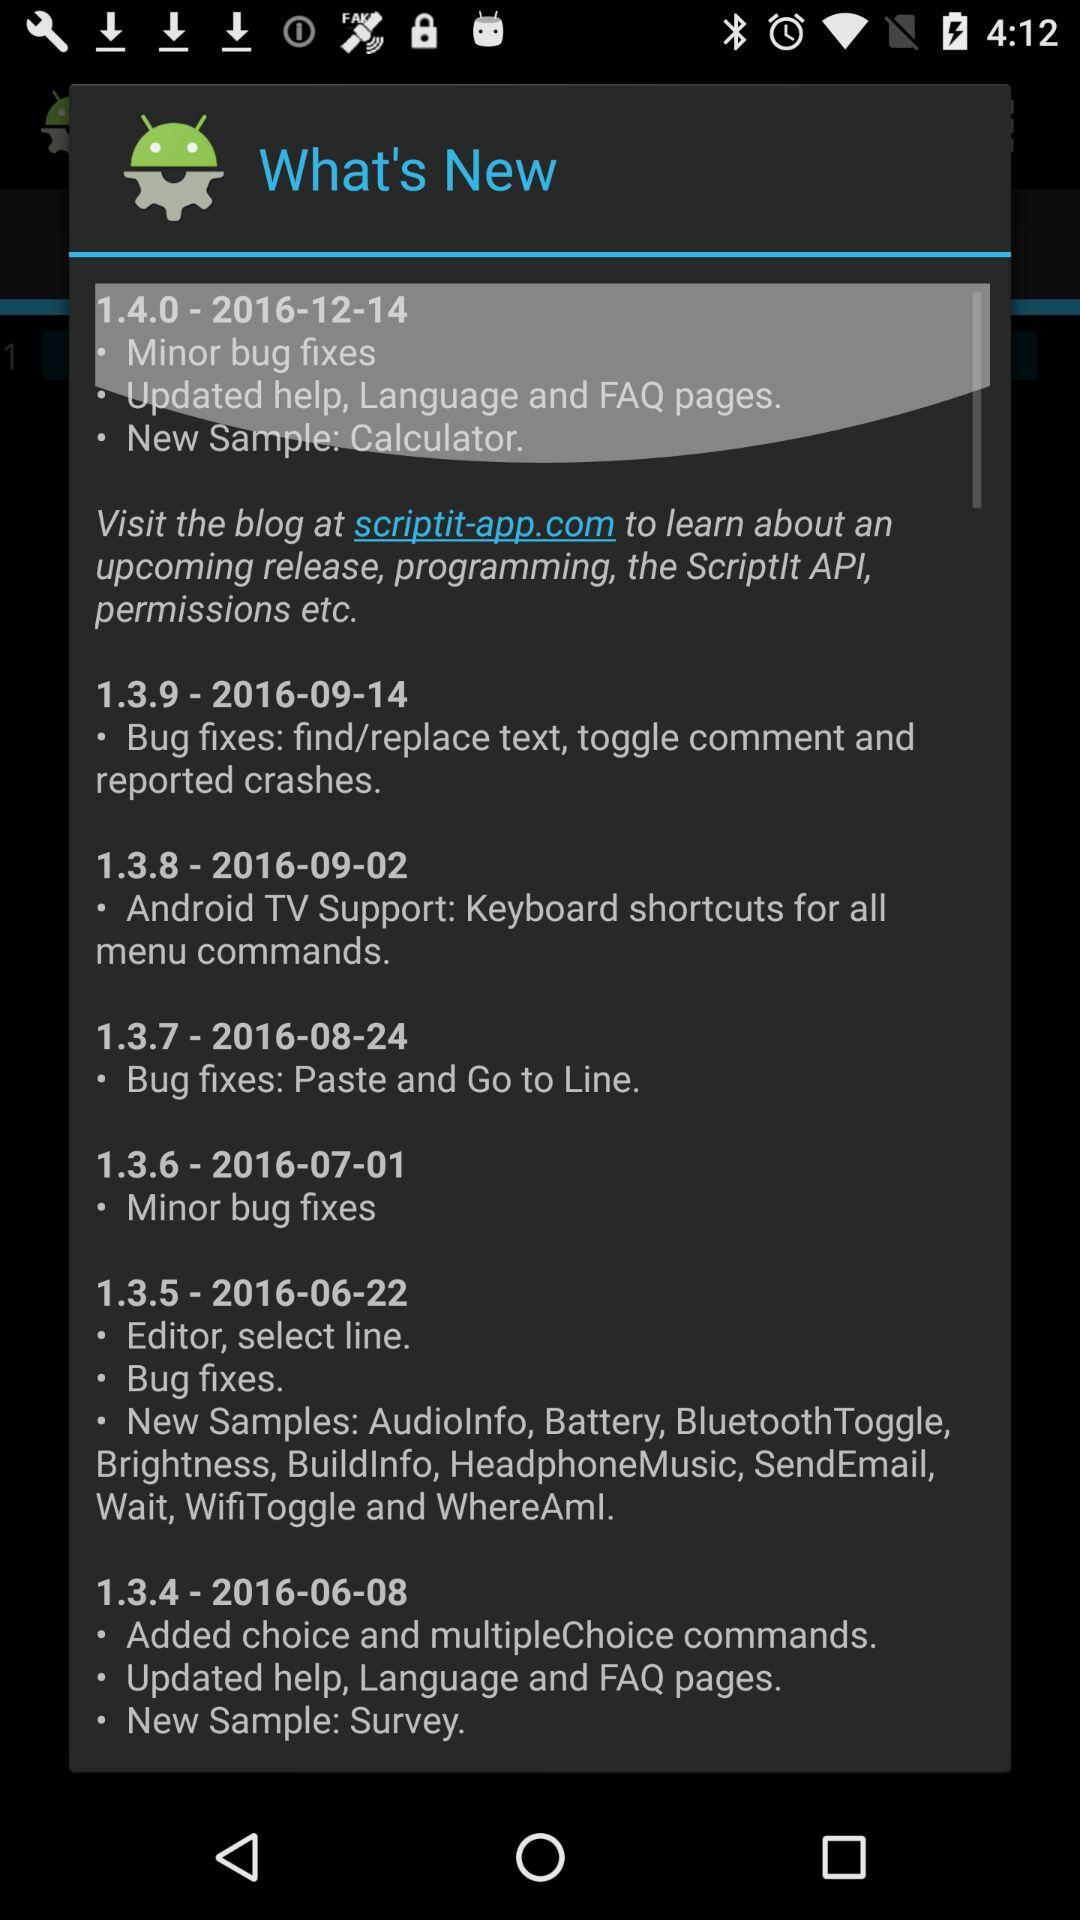On what date was Version 1.3.5 updated? Version 1.3.5 was updated on June 22, 2016. 